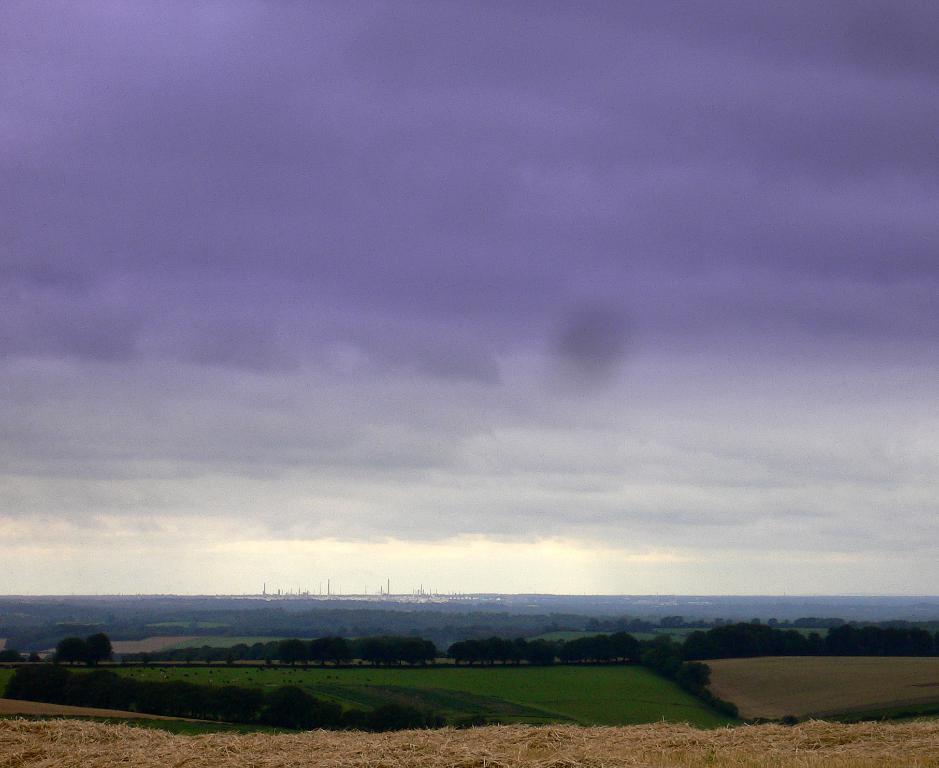What type of vegetation can be seen in the image? There are trees in the image. What else can be seen on the ground in the image? There is grass in the image. What is visible in the background of the image? The sky is visible in the image. What can be observed in the sky? Clouds are present in the sky. What is the most comfortable way to sit on the clouds in the image? There are no people in the image, and the clouds are not tangible, so it is not possible to sit on them or determine the most comfortable way to do so. 